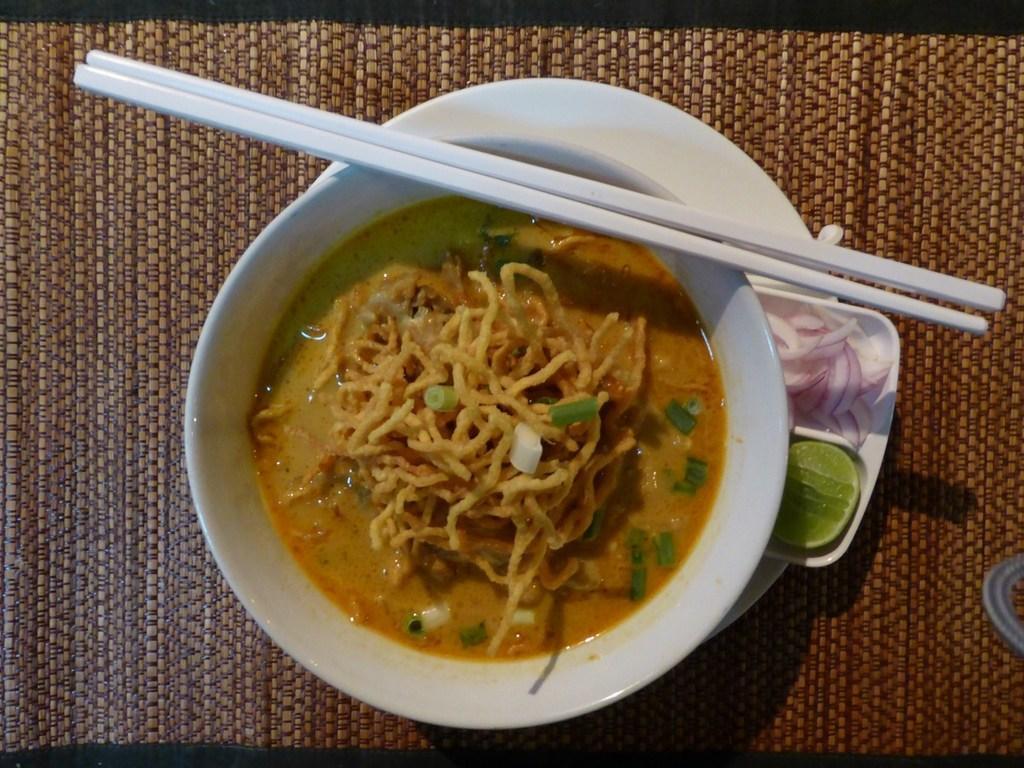Please provide a concise description of this image. In this picture we can see food in the bowl. These are chopsticks and there is a plate. And there are onions, and lemon. 